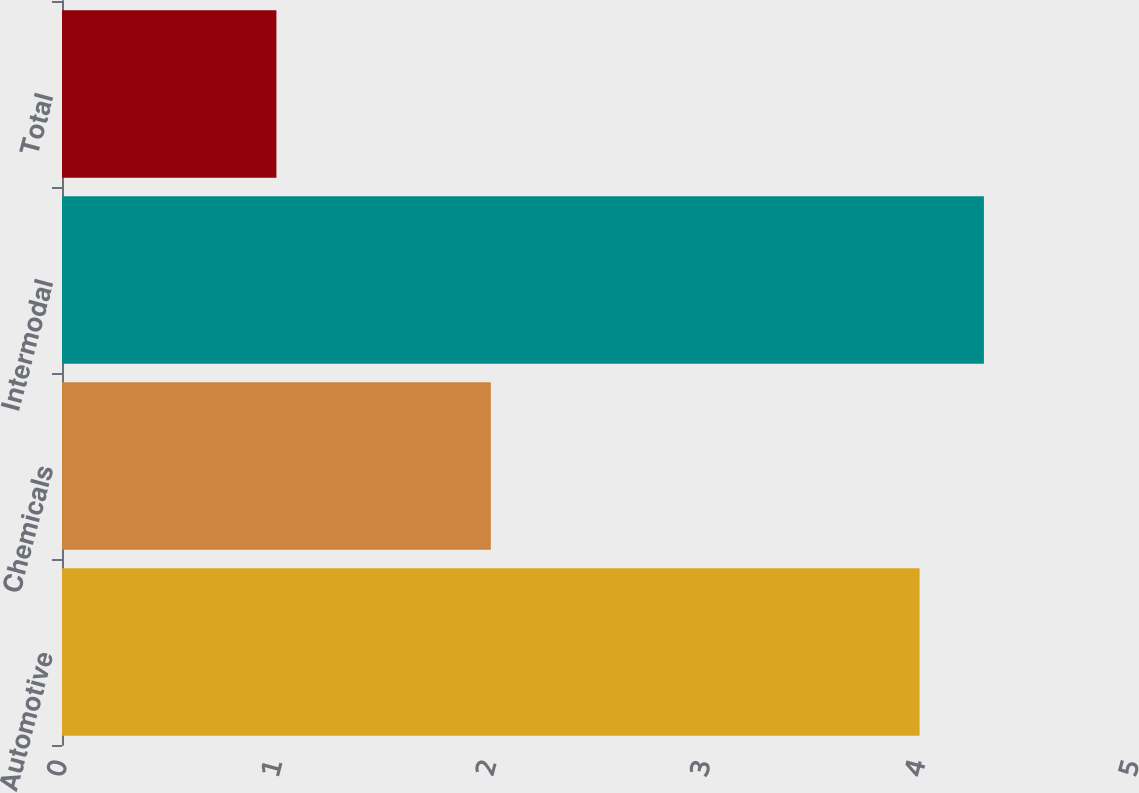Convert chart to OTSL. <chart><loc_0><loc_0><loc_500><loc_500><bar_chart><fcel>Automotive<fcel>Chemicals<fcel>Intermodal<fcel>Total<nl><fcel>4<fcel>2<fcel>4.3<fcel>1<nl></chart> 